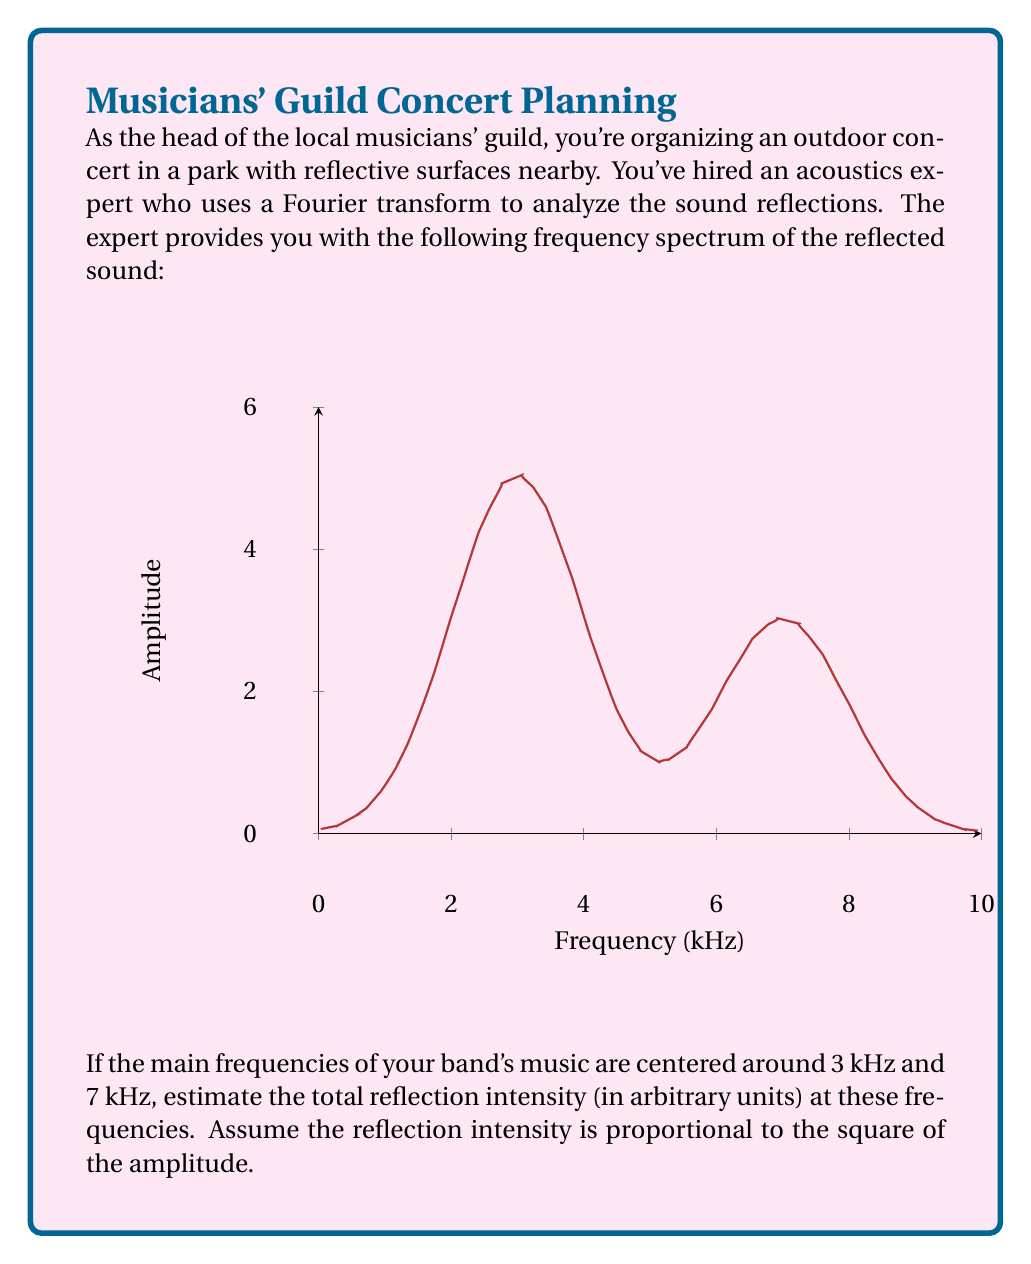Help me with this question. Let's approach this step-by-step:

1) The graph shows two peaks in the frequency spectrum, centered at 3 kHz and 7 kHz, which align with the main frequencies of the band's music.

2) We need to estimate the amplitudes at these frequencies:
   - At 3 kHz, the amplitude is approximately 5 units
   - At 7 kHz, the amplitude is approximately 3 units

3) The reflection intensity is proportional to the square of the amplitude. So we need to square these values:
   - At 3 kHz: $5^2 = 25$ units
   - At 7 kHz: $3^2 = 9$ units

4) To get the total reflection intensity, we sum these values:

   $$\text{Total Intensity} = 25 + 9 = 34 \text{ units}$$

This calculation gives us an estimate of the total reflection intensity at the main frequencies of the band's music.
Answer: 34 units 